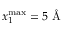Convert formula to latex. <formula><loc_0><loc_0><loc_500><loc_500>x _ { 1 } ^ { \max } = 5 \AA</formula> 